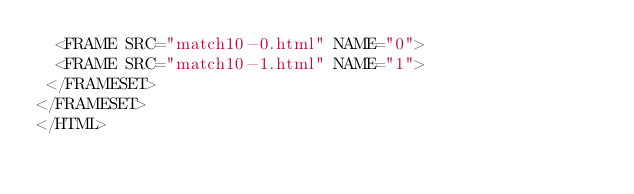<code> <loc_0><loc_0><loc_500><loc_500><_HTML_>  <FRAME SRC="match10-0.html" NAME="0">
  <FRAME SRC="match10-1.html" NAME="1">
 </FRAMESET>
</FRAMESET>
</HTML>
</code> 